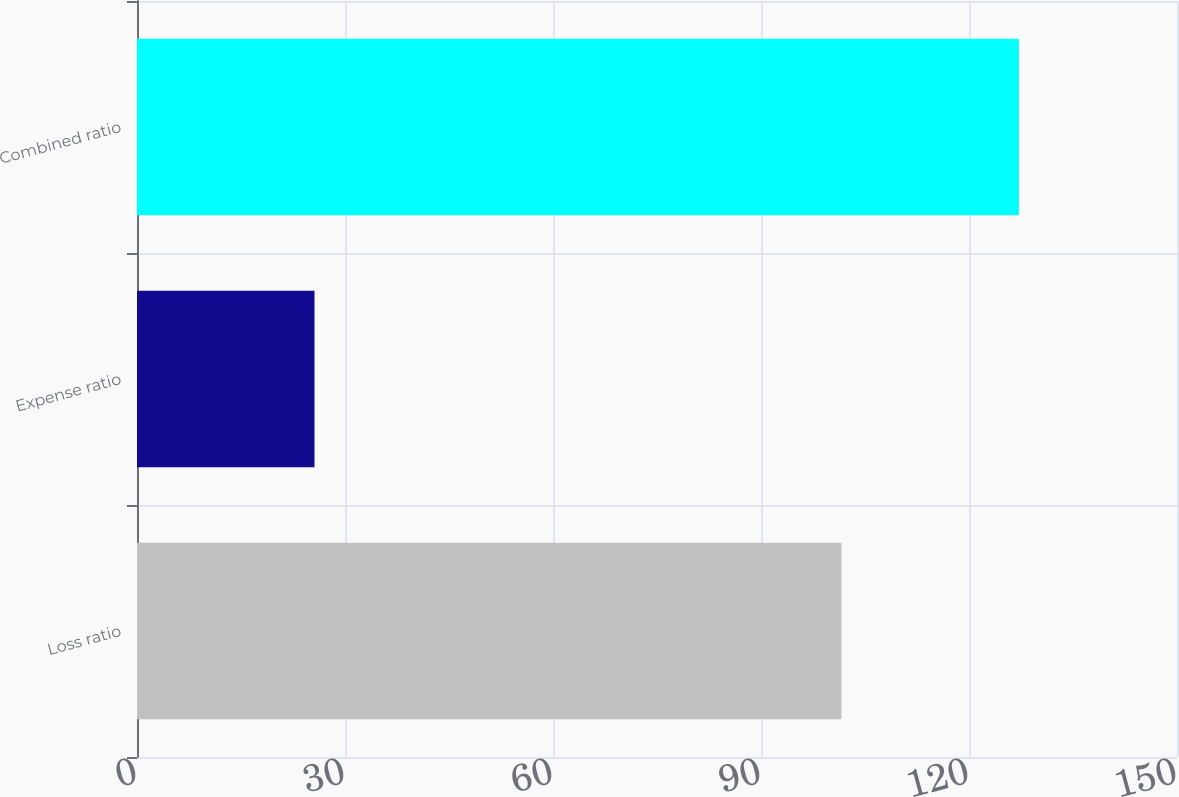Convert chart. <chart><loc_0><loc_0><loc_500><loc_500><bar_chart><fcel>Loss ratio<fcel>Expense ratio<fcel>Combined ratio<nl><fcel>101.6<fcel>25.6<fcel>127.2<nl></chart> 